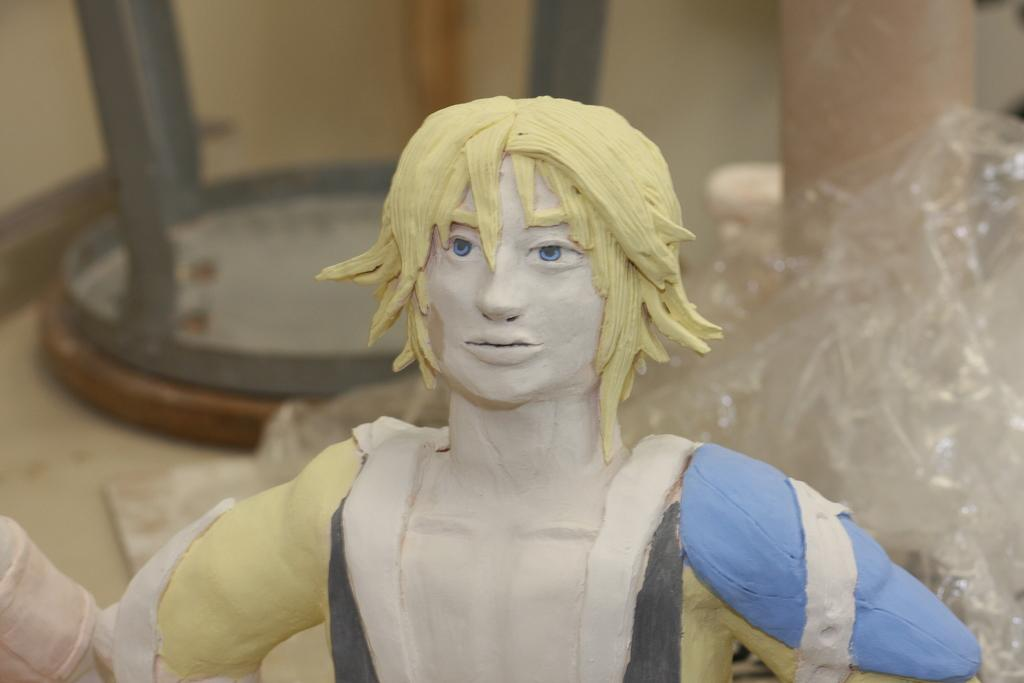What is the main subject in the image? There is a statue in the image. What else can be seen on the ground in the image? There is an object on the ground in the image. Is there any protective covering in the image? Yes, there is a cover in the image. What architectural feature is present in the image? There is a pillar in the image. What type of stone is the clock made of in the image? There is no clock present in the image, so it is not possible to determine what type of stone it might be made of. 